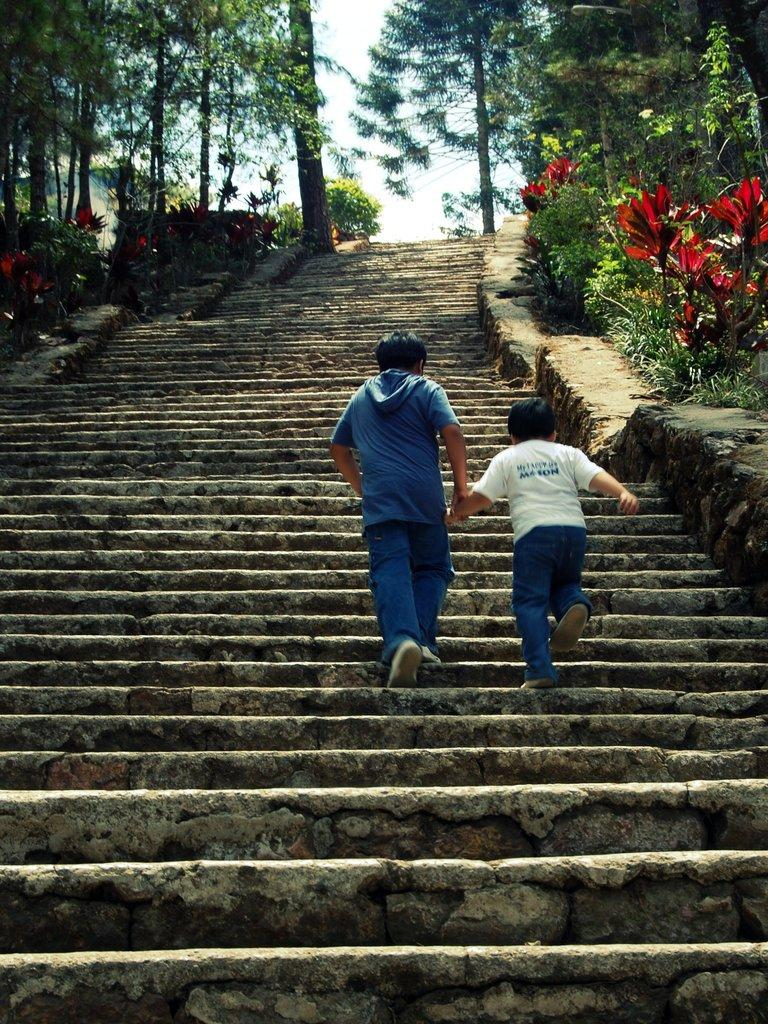What are the persons in the image doing? The persons in the image are climbing stairs. What can be seen in the background of the image? There are trees in the image. What type of punishment is being administered to the horse in the image? There is no horse present in the image, and therefore no punishment is being administered. Can you describe the tiger's behavior in the image? There is no tiger present in the image, so its behavior cannot be described. 